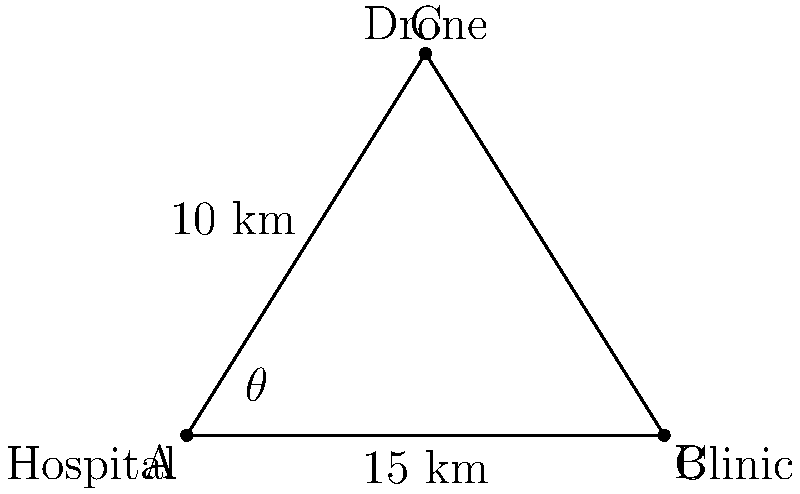A drone is delivering medical supplies from a hospital to a clinic. The drone is currently at point C, 10 km away from the hospital (point A) and 8 km above the ground. The clinic (point B) is 15 km away from the hospital along a straight line on the ground. What is the optimal angle $\theta$ for the drone's flight path to minimize delivery time, assuming the drone flies at a constant speed? To find the optimal angle for the drone's flight path, we need to minimize the distance from the drone to the clinic. This can be done using the following steps:

1) First, let's identify the triangle formed by the drone's position (C), the hospital (A), and the clinic (B).

2) We know:
   AC = 10 km (height of the drone)
   AB = 15 km (distance between hospital and clinic)

3) To find the optimal angle, we need to minimize the length of CB. We can use the Pythagorean theorem:

   $$CB^2 = x^2 + (15-x)^2 + 8^2$$

   where x is the distance along the ground from A to the point directly below the drone.

4) To minimize CB, we differentiate this equation with respect to x and set it to zero:

   $$\frac{d}{dx}(CB^2) = 2x + 2(15-x)(-1) = 0$$

5) Solving this equation:
   $$2x - 30 + 2x = 0$$
   $$4x = 30$$
   $$x = 7.5$$

6) This means the optimal point for the drone to fly towards is exactly halfway between A and B.

7) Now we can calculate the angle $\theta$:

   $$\tan(\theta) = \frac{10}{7.5} = \frac{4}{3}$$

8) Therefore:

   $$\theta = \arctan(\frac{4}{3}) \approx 53.13°$$
Answer: $53.13°$ 